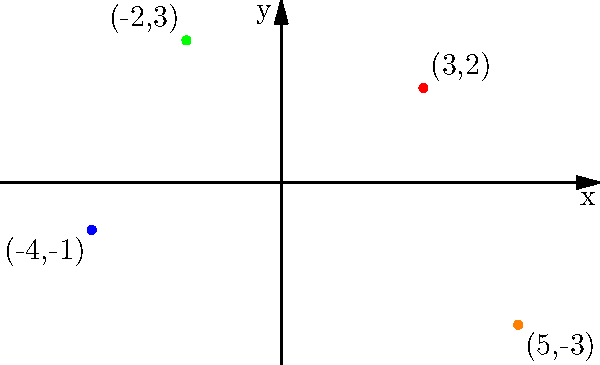Identify the quadrants for each of the following points on the coordinate plane: $(3,2)$, $(-4,-1)$, $(-2,3)$, and $(5,-3)$. How would you explain the process of determining quadrants to a student who is struggling with this concept? To determine the quadrant of a point, we need to consider its x and y coordinates. Here's a step-by-step process:

1. Recall the quadrant definitions:
   - Quadrant I: Both x and y are positive (x > 0, y > 0)
   - Quadrant II: x is negative, y is positive (x < 0, y > 0)
   - Quadrant III: Both x and y are negative (x < 0, y < 0)
   - Quadrant IV: x is positive, y is negative (x > 0, y < 0)

2. For each point:
   a) $(3,2)$: x = 3 (positive), y = 2 (positive) → Quadrant I
   b) $(-4,-1)$: x = -4 (negative), y = -1 (negative) → Quadrant III
   c) $(-2,3)$: x = -2 (negative), y = 3 (positive) → Quadrant II
   d) $(5,-3)$: x = 5 (positive), y = -3 (negative) → Quadrant IV

3. To explain this to a struggling student:
   - Draw a large coordinate plane and label the quadrants.
   - Use different colored dots for each point.
   - Guide the student to look at the signs of x and y for each point.
   - Encourage them to think of the quadrants as "rooms" in a house, each with its own sign combination.
   - Practice with more examples, gradually reducing guidance.
Answer: $(3,2)$: I, $(-4,-1)$: III, $(-2,3)$: II, $(5,-3)$: IV 